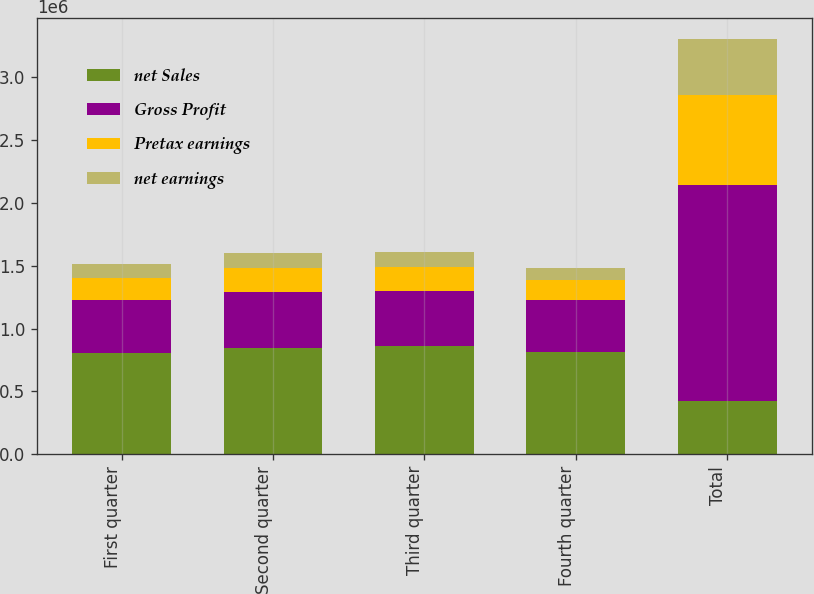<chart> <loc_0><loc_0><loc_500><loc_500><stacked_bar_chart><ecel><fcel>First quarter<fcel>Second quarter<fcel>Third quarter<fcel>Fourth quarter<fcel>Total<nl><fcel>net Sales<fcel>806326<fcel>847596<fcel>858424<fcel>813760<fcel>421880<nl><fcel>Gross Profit<fcel>421880<fcel>442721<fcel>443395<fcel>411449<fcel>1.71944e+06<nl><fcel>Pretax earnings<fcel>175172<fcel>192379<fcel>188643<fcel>157274<fcel>713468<nl><fcel>net earnings<fcel>109048<fcel>121009<fcel>119350<fcel>99229<fcel>448636<nl></chart> 